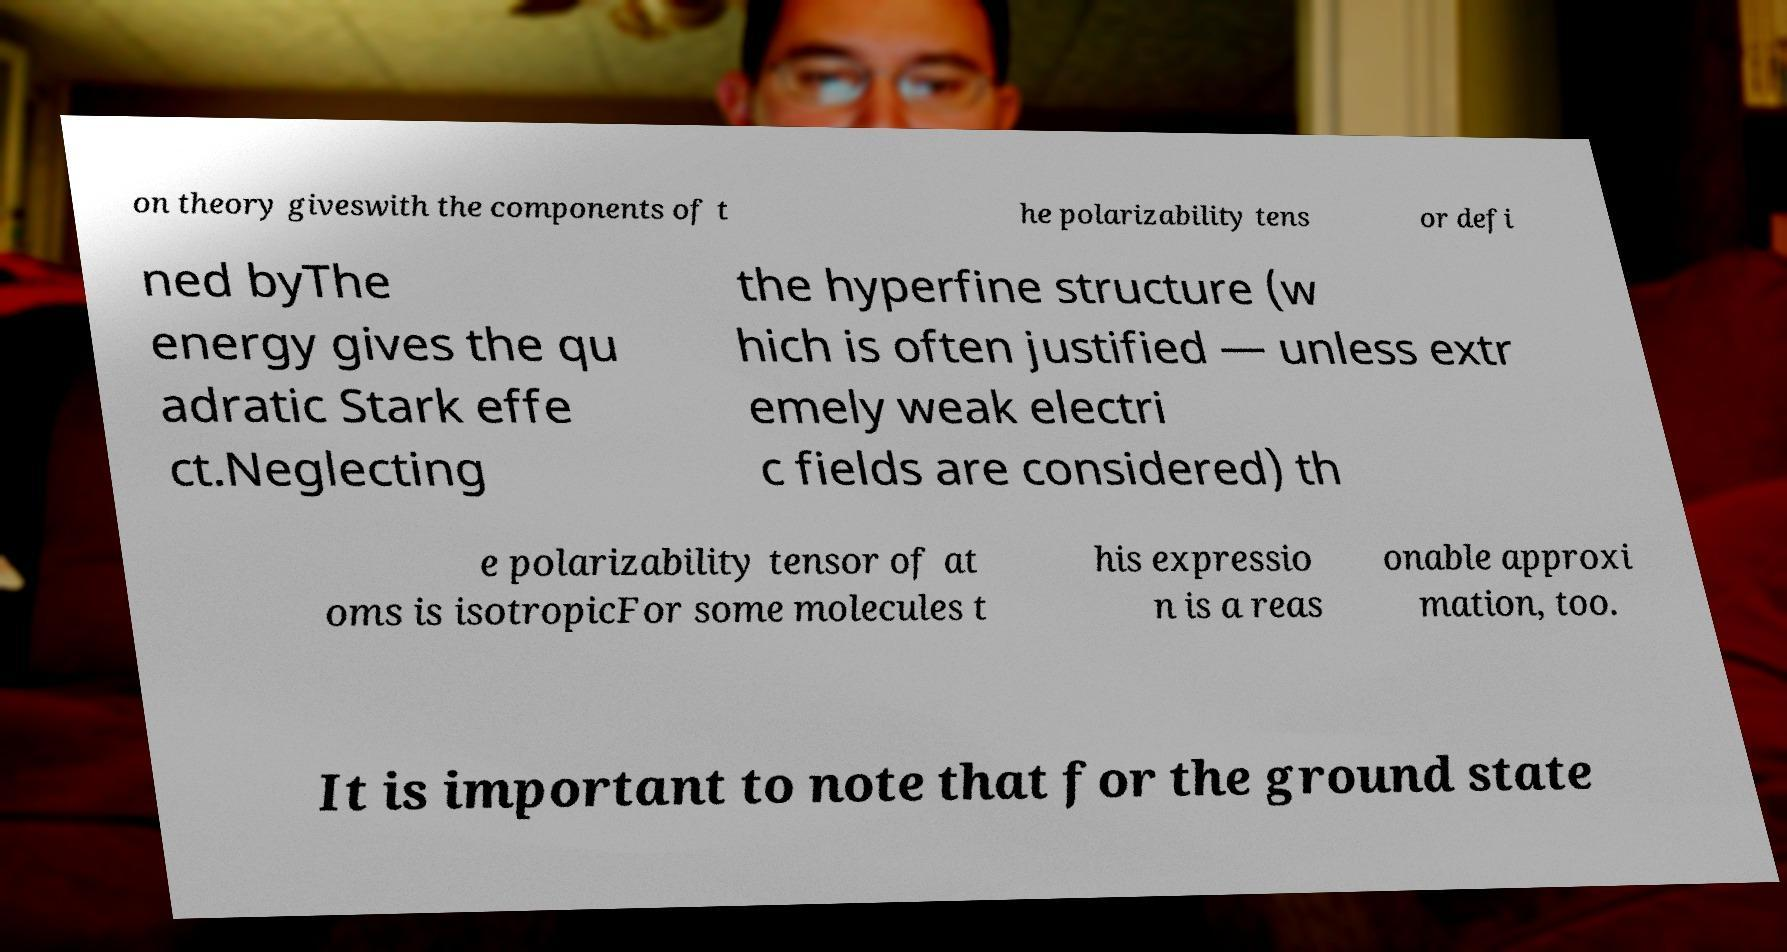There's text embedded in this image that I need extracted. Can you transcribe it verbatim? on theory giveswith the components of t he polarizability tens or defi ned byThe energy gives the qu adratic Stark effe ct.Neglecting the hyperfine structure (w hich is often justified — unless extr emely weak electri c fields are considered) th e polarizability tensor of at oms is isotropicFor some molecules t his expressio n is a reas onable approxi mation, too. It is important to note that for the ground state 